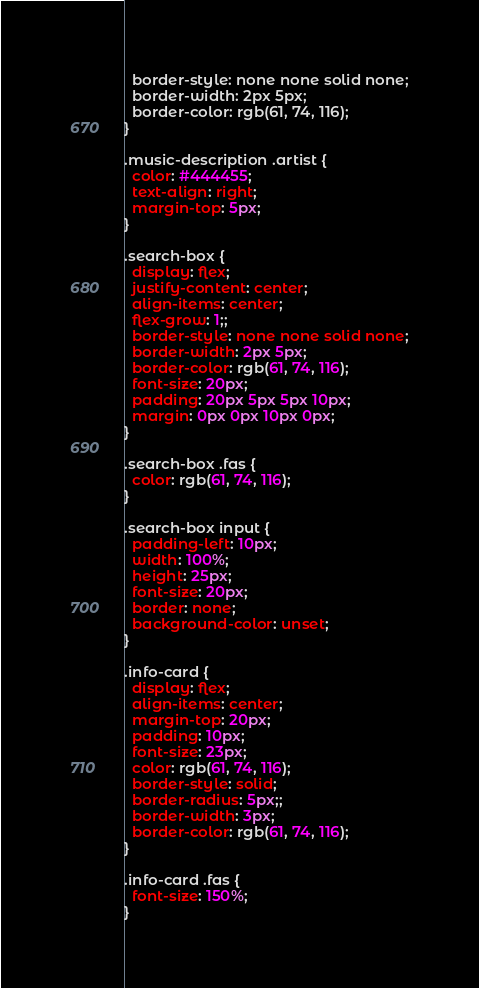<code> <loc_0><loc_0><loc_500><loc_500><_CSS_>  border-style: none none solid none;
  border-width: 2px 5px;
  border-color: rgb(61, 74, 116);
}

.music-description .artist {
  color: #444455;
  text-align: right;
  margin-top: 5px;
}

.search-box {
  display: flex;
  justify-content: center;
  align-items: center;
  flex-grow: 1;;
  border-style: none none solid none;
  border-width: 2px 5px;
  border-color: rgb(61, 74, 116);
  font-size: 20px;
  padding: 20px 5px 5px 10px;
  margin: 0px 0px 10px 0px;
}

.search-box .fas {
  color: rgb(61, 74, 116);
}

.search-box input {
  padding-left: 10px;
  width: 100%;
  height: 25px;
  font-size: 20px;
  border: none;
  background-color: unset;
}

.info-card {
  display: flex;
  align-items: center;
  margin-top: 20px;
  padding: 10px;
  font-size: 23px;
  color: rgb(61, 74, 116);
  border-style: solid;
  border-radius: 5px;;
  border-width: 3px;
  border-color: rgb(61, 74, 116);
}

.info-card .fas {
  font-size: 150%;
}
</code> 